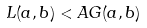<formula> <loc_0><loc_0><loc_500><loc_500>L ( a , b ) < A G ( a , b )</formula> 